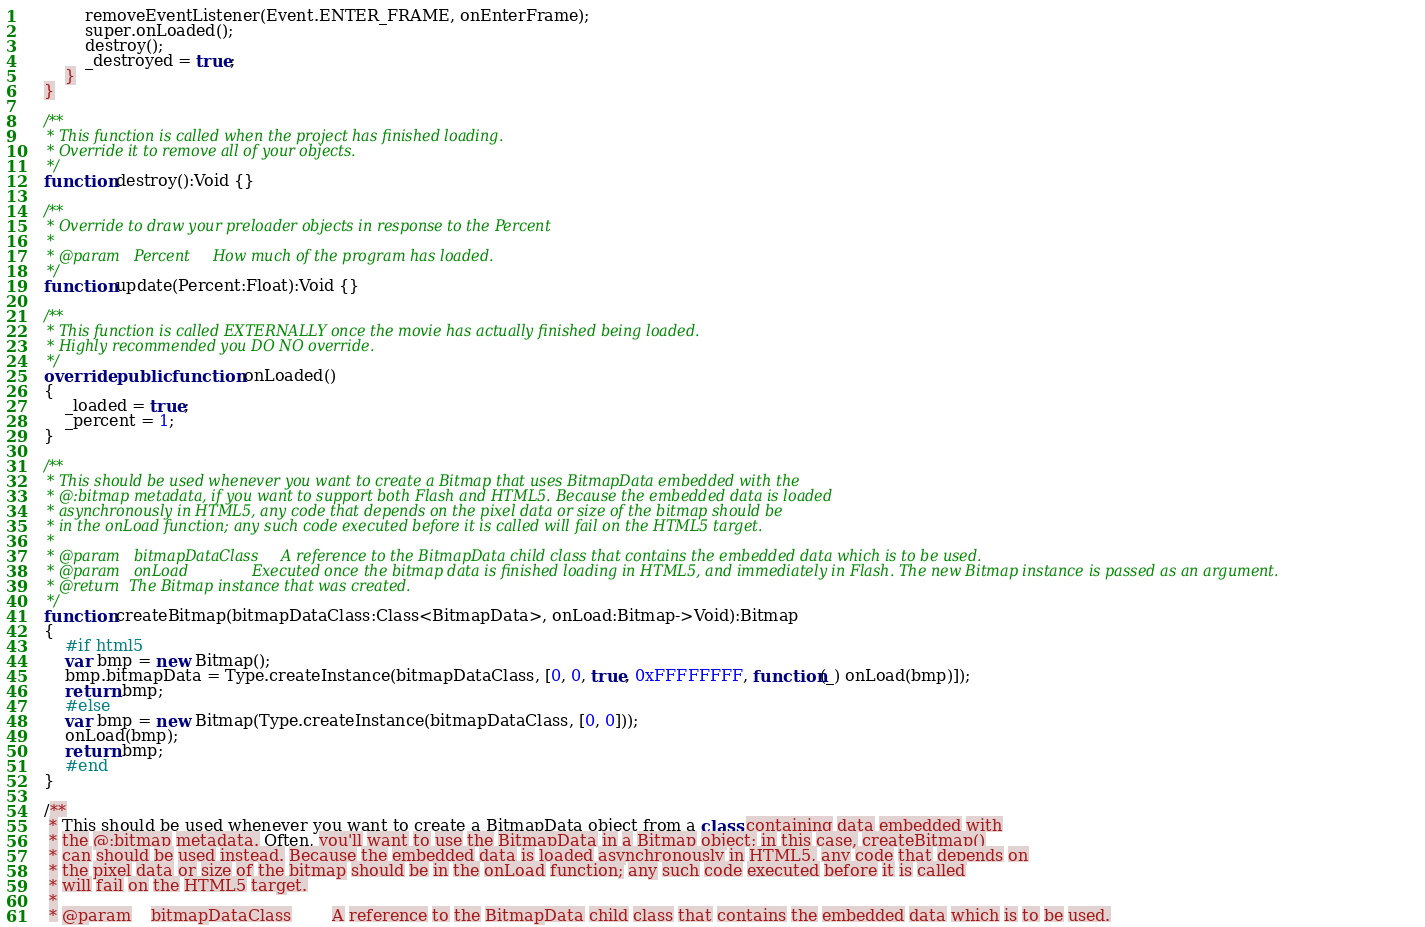<code> <loc_0><loc_0><loc_500><loc_500><_Haxe_>			removeEventListener(Event.ENTER_FRAME, onEnterFrame);
			super.onLoaded();
			destroy();
			_destroyed = true;
		}
	}

	/**
	 * This function is called when the project has finished loading.
	 * Override it to remove all of your objects.
	 */
	function destroy():Void {}

	/**
	 * Override to draw your preloader objects in response to the Percent
	 *
	 * @param	Percent		How much of the program has loaded.
	 */
	function update(Percent:Float):Void {}

	/**
	 * This function is called EXTERNALLY once the movie has actually finished being loaded.
	 * Highly recommended you DO NO override.
	 */
	override public function onLoaded()
	{
		_loaded = true;
		_percent = 1;
	}

	/**
	 * This should be used whenever you want to create a Bitmap that uses BitmapData embedded with the
	 * @:bitmap metadata, if you want to support both Flash and HTML5. Because the embedded data is loaded
	 * asynchronously in HTML5, any code that depends on the pixel data or size of the bitmap should be
	 * in the onLoad function; any such code executed before it is called will fail on the HTML5 target.
	 *
	 * @param	bitmapDataClass		A reference to the BitmapData child class that contains the embedded data which is to be used.
	 * @param	onLoad				Executed once the bitmap data is finished loading in HTML5, and immediately in Flash. The new Bitmap instance is passed as an argument.
	 * @return  The Bitmap instance that was created.
	 */
	function createBitmap(bitmapDataClass:Class<BitmapData>, onLoad:Bitmap->Void):Bitmap
	{
		#if html5
		var bmp = new Bitmap();
		bmp.bitmapData = Type.createInstance(bitmapDataClass, [0, 0, true, 0xFFFFFFFF, function(_) onLoad(bmp)]);
		return bmp;
		#else
		var bmp = new Bitmap(Type.createInstance(bitmapDataClass, [0, 0]));
		onLoad(bmp);
		return bmp;
		#end
	}

	/**
	 * This should be used whenever you want to create a BitmapData object from a class containing data embedded with
	 * the @:bitmap metadata. Often, you'll want to use the BitmapData in a Bitmap object; in this case, createBitmap()
	 * can should be used instead. Because the embedded data is loaded asynchronously in HTML5, any code that depends on
	 * the pixel data or size of the bitmap should be in the onLoad function; any such code executed before it is called
	 * will fail on the HTML5 target.
	 *
	 * @param	bitmapDataClass		A reference to the BitmapData child class that contains the embedded data which is to be used.</code> 